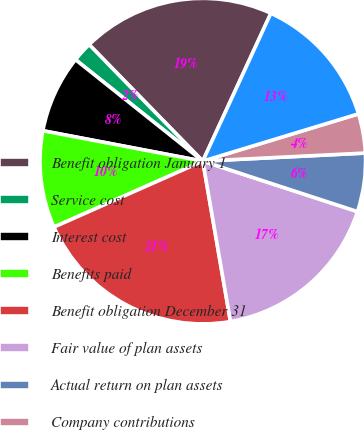Convert chart to OTSL. <chart><loc_0><loc_0><loc_500><loc_500><pie_chart><fcel>Benefit obligation January 1<fcel>Service cost<fcel>Interest cost<fcel>Benefits paid<fcel>Benefit obligation December 31<fcel>Fair value of plan assets<fcel>Actual return on plan assets<fcel>Company contributions<fcel>Funded status December 31<nl><fcel>19.17%<fcel>1.99%<fcel>7.72%<fcel>9.63%<fcel>21.08%<fcel>17.26%<fcel>5.81%<fcel>3.9%<fcel>13.44%<nl></chart> 